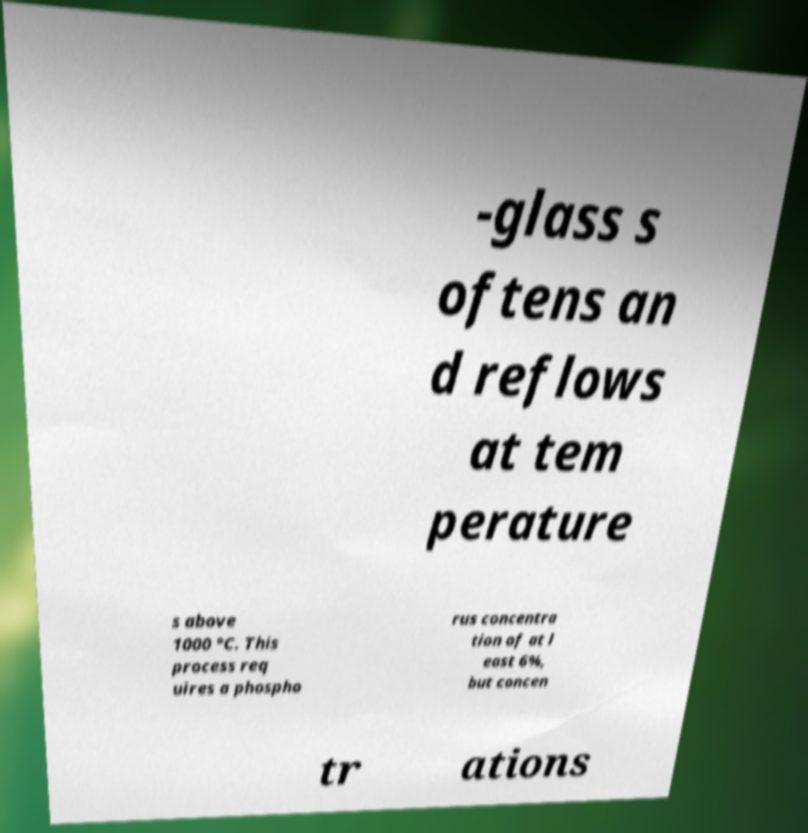Please identify and transcribe the text found in this image. -glass s oftens an d reflows at tem perature s above 1000 °C. This process req uires a phospho rus concentra tion of at l east 6%, but concen tr ations 